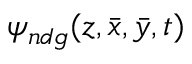<formula> <loc_0><loc_0><loc_500><loc_500>\psi _ { n d g } ( z , \bar { x } , \bar { y } , t )</formula> 